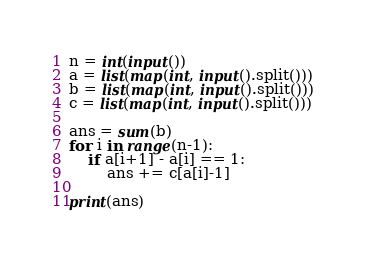Convert code to text. <code><loc_0><loc_0><loc_500><loc_500><_Python_>n = int(input())
a = list(map(int, input().split()))
b = list(map(int, input().split()))
c = list(map(int, input().split()))

ans = sum(b)
for i in range(n-1):
    if a[i+1] - a[i] == 1:
        ans += c[a[i]-1]

print(ans)</code> 